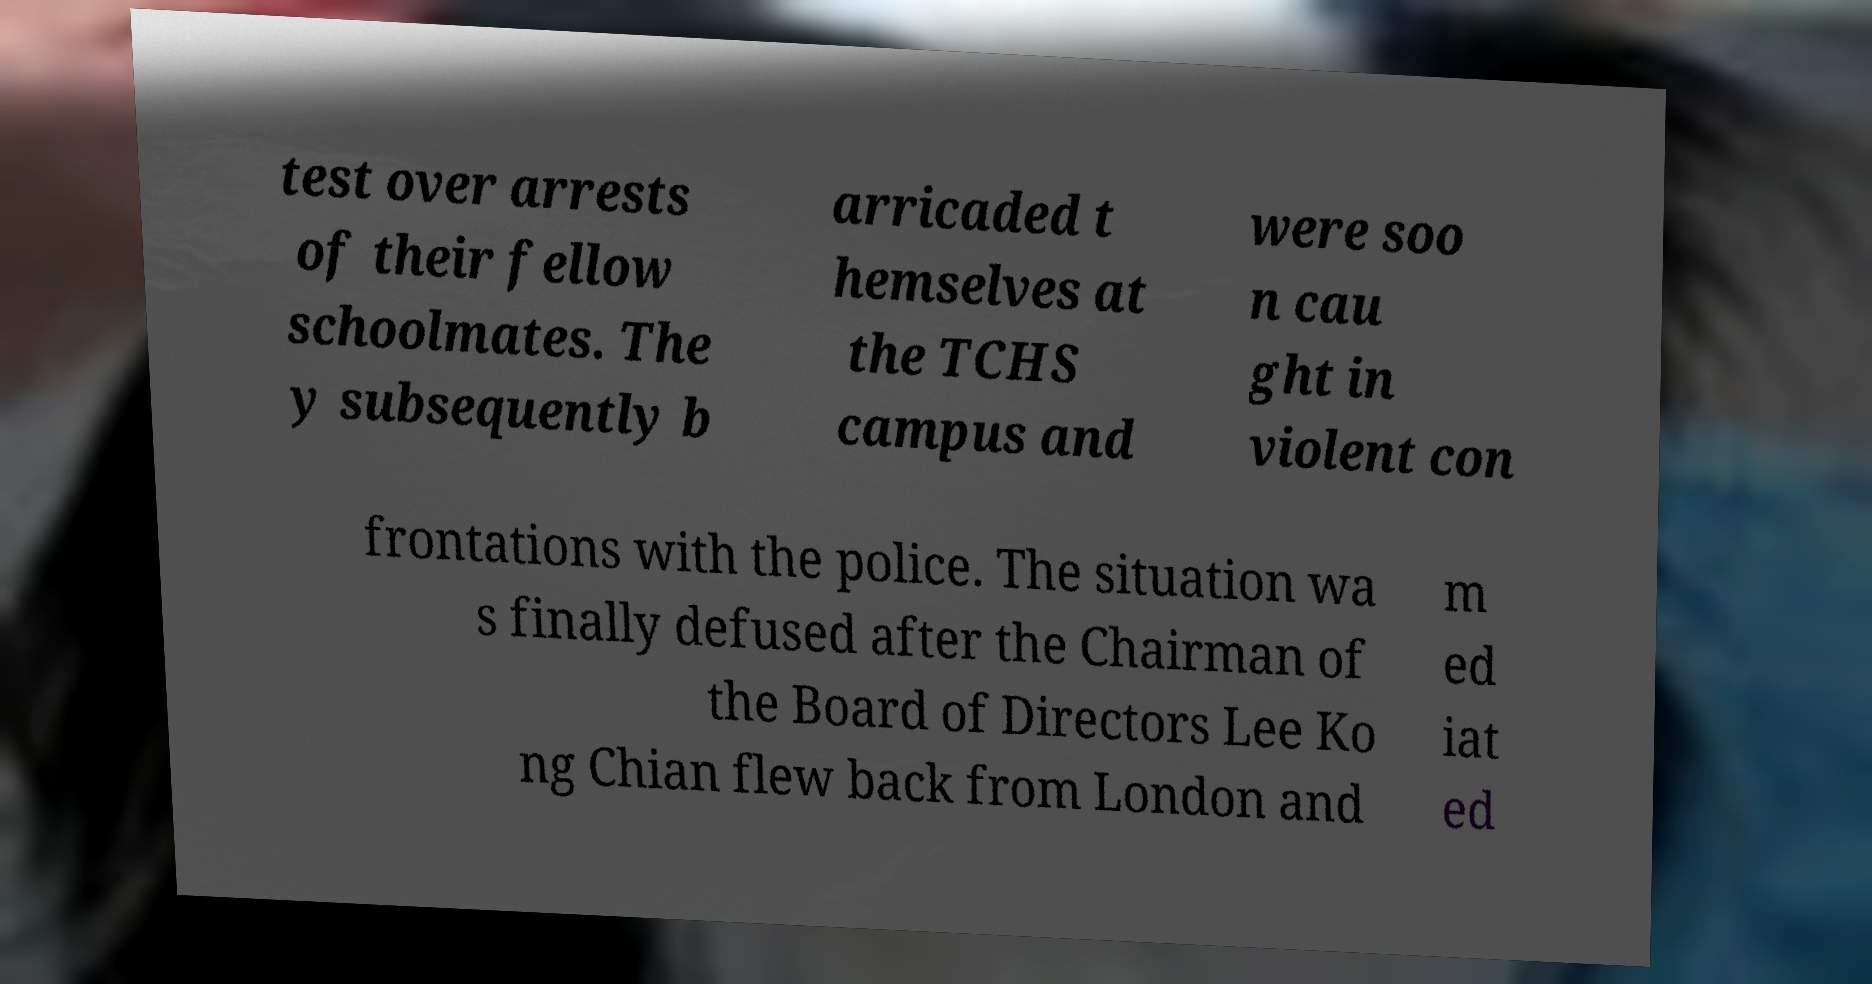Can you read and provide the text displayed in the image?This photo seems to have some interesting text. Can you extract and type it out for me? test over arrests of their fellow schoolmates. The y subsequently b arricaded t hemselves at the TCHS campus and were soo n cau ght in violent con frontations with the police. The situation wa s finally defused after the Chairman of the Board of Directors Lee Ko ng Chian flew back from London and m ed iat ed 